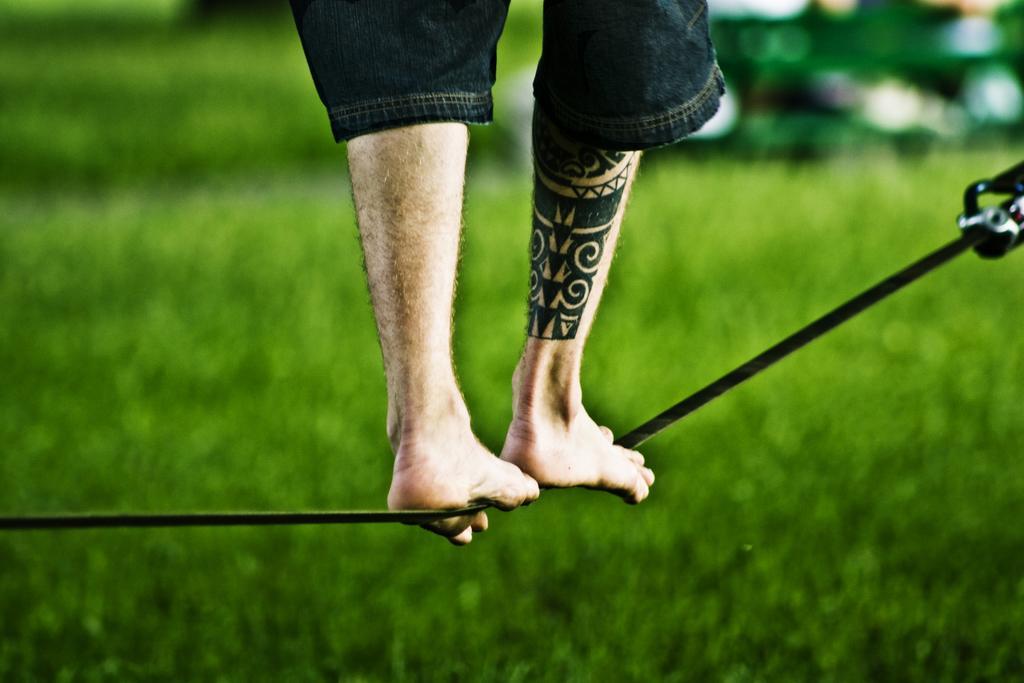Can you describe this image briefly? In this picture we can see the legs of a person on a black rope. We can see a tattoo on a person's calf. At the bottom portion of the picture we can see grass. Background portion of the picture is blurred. 